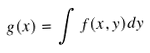<formula> <loc_0><loc_0><loc_500><loc_500>g ( x ) = \int f ( x , y ) d y</formula> 